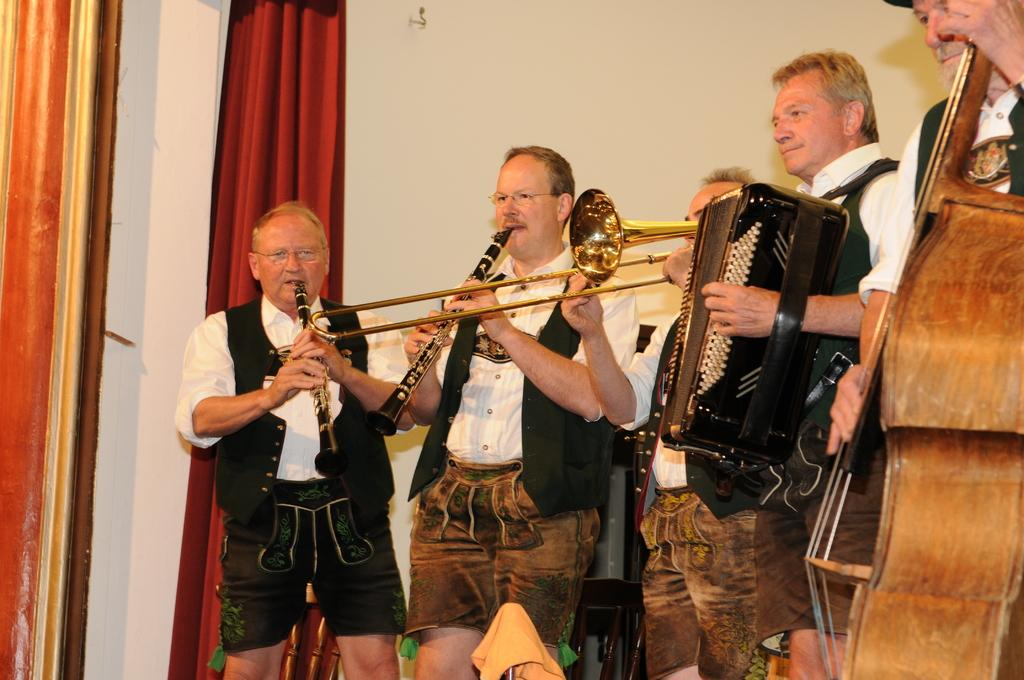What are the people in the foreground of the image doing? The people in the foreground of the image are playing musical instruments. What can be seen in the background of the image? There are curtains in the background of the image. What type of wire is being used as a prop in the image? There is no wire present in the image; the people are playing musical instruments without any visible props. 